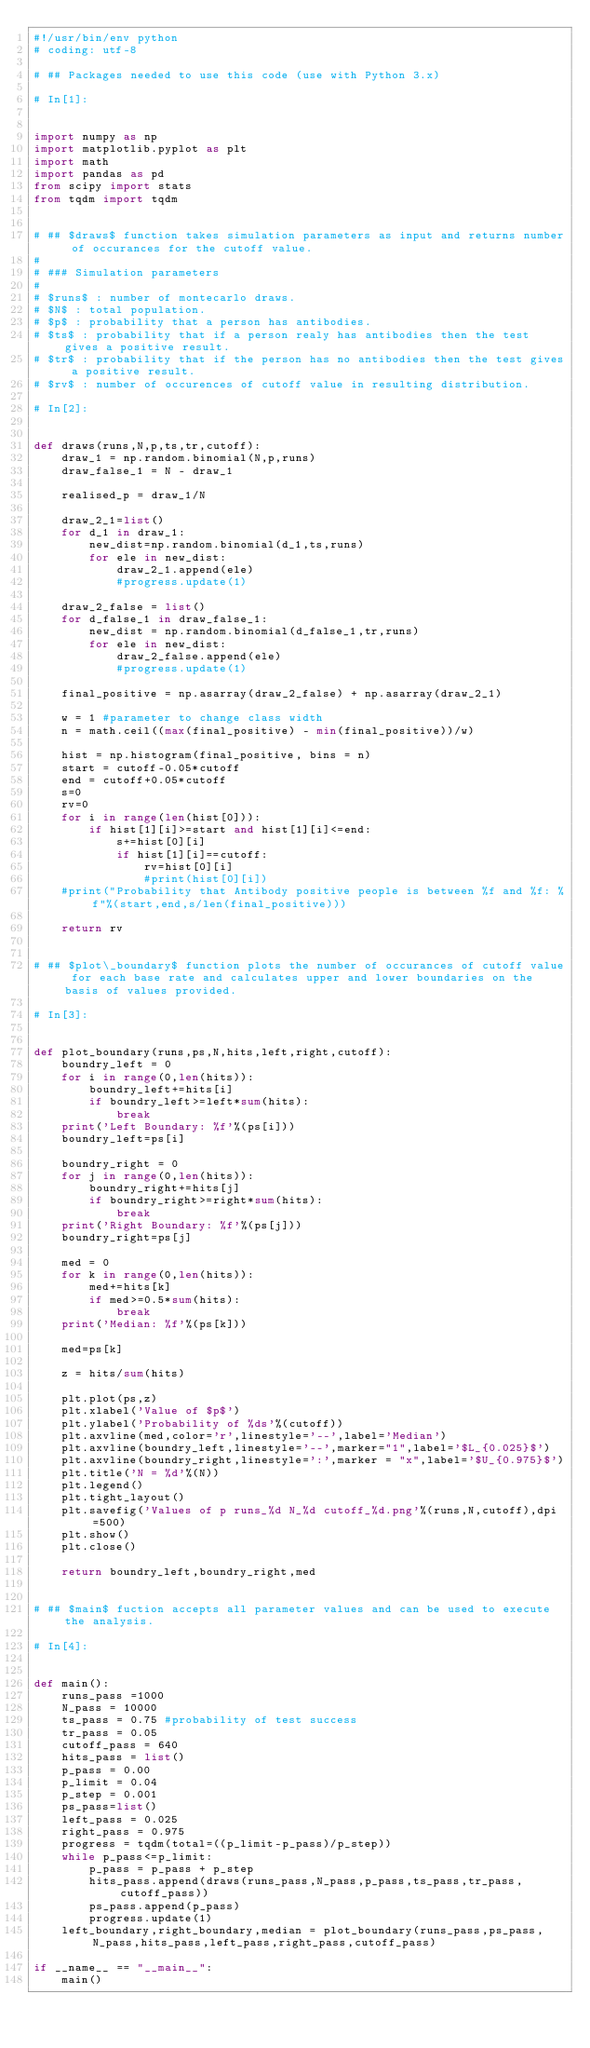<code> <loc_0><loc_0><loc_500><loc_500><_Python_>#!/usr/bin/env python
# coding: utf-8

# ## Packages needed to use this code (use with Python 3.x)

# In[1]:


import numpy as np
import matplotlib.pyplot as plt
import math
import pandas as pd
from scipy import stats
from tqdm import tqdm


# ## $draws$ function takes simulation parameters as input and returns number of occurances for the cutoff value.
# 
# ### Simulation parameters
# 
# $runs$ : number of montecarlo draws.  
# $N$ : total population.  
# $p$ : probability that a person has antibodies.  
# $ts$ : probability that if a person realy has antibodies then the test gives a positive result.  
# $tr$ : probability that if the person has no antibodies then the test gives a positive result.  
# $rv$ : number of occurences of cutoff value in resulting distribution.  

# In[2]:


def draws(runs,N,p,ts,tr,cutoff):
    draw_1 = np.random.binomial(N,p,runs)
    draw_false_1 = N - draw_1

    realised_p = draw_1/N

    draw_2_1=list()
    for d_1 in draw_1:
        new_dist=np.random.binomial(d_1,ts,runs)
        for ele in new_dist:
            draw_2_1.append(ele)
            #progress.update(1)

    draw_2_false = list()
    for d_false_1 in draw_false_1:
        new_dist = np.random.binomial(d_false_1,tr,runs)
        for ele in new_dist:
            draw_2_false.append(ele)
            #progress.update(1)

    final_positive = np.asarray(draw_2_false) + np.asarray(draw_2_1)

    w = 1 #parameter to change class width
    n = math.ceil((max(final_positive) - min(final_positive))/w)

    hist = np.histogram(final_positive, bins = n)
    start = cutoff-0.05*cutoff
    end = cutoff+0.05*cutoff
    s=0
    rv=0
    for i in range(len(hist[0])):
        if hist[1][i]>=start and hist[1][i]<=end:
            s+=hist[0][i]
            if hist[1][i]==cutoff:
                rv=hist[0][i]
                #print(hist[0][i])
    #print("Probability that Antibody positive people is between %f and %f: %f"%(start,end,s/len(final_positive)))

    return rv


# ## $plot\_boundary$ function plots the number of occurances of cutoff value for each base rate and calculates upper and lower boundaries on the basis of values provided.

# In[3]:


def plot_boundary(runs,ps,N,hits,left,right,cutoff):
    boundry_left = 0
    for i in range(0,len(hits)):
        boundry_left+=hits[i]
        if boundry_left>=left*sum(hits):
            break
    print('Left Boundary: %f'%(ps[i]))
    boundry_left=ps[i]

    boundry_right = 0
    for j in range(0,len(hits)):
        boundry_right+=hits[j]
        if boundry_right>=right*sum(hits):
            break
    print('Right Boundary: %f'%(ps[j]))
    boundry_right=ps[j]

    med = 0
    for k in range(0,len(hits)):
        med+=hits[k]
        if med>=0.5*sum(hits):
            break
    print('Median: %f'%(ps[k]))

    med=ps[k]

    z = hits/sum(hits)

    plt.plot(ps,z)
    plt.xlabel('Value of $p$')
    plt.ylabel('Probability of %ds'%(cutoff))
    plt.axvline(med,color='r',linestyle='--',label='Median')
    plt.axvline(boundry_left,linestyle='--',marker="1",label='$L_{0.025}$')
    plt.axvline(boundry_right,linestyle=':',marker = "x",label='$U_{0.975}$')
    plt.title('N = %d'%(N))
    plt.legend()
    plt.tight_layout()
    plt.savefig('Values of p runs_%d N_%d cutoff_%d.png'%(runs,N,cutoff),dpi=500)
    plt.show()
    plt.close()
    
    return boundry_left,boundry_right,med


# ## $main$ fuction accepts all parameter values and can be used to execute the analysis.

# In[4]:


def main():
    runs_pass =1000
    N_pass = 10000
    ts_pass = 0.75 #probability of test success
    tr_pass = 0.05
    cutoff_pass = 640
    hits_pass = list()
    p_pass = 0.00
    p_limit = 0.04
    p_step = 0.001
    ps_pass=list()
    left_pass = 0.025
    right_pass = 0.975
    progress = tqdm(total=((p_limit-p_pass)/p_step))
    while p_pass<=p_limit:
        p_pass = p_pass + p_step
        hits_pass.append(draws(runs_pass,N_pass,p_pass,ts_pass,tr_pass,cutoff_pass))
        ps_pass.append(p_pass)
        progress.update(1)
    left_boundary,right_boundary,median = plot_boundary(runs_pass,ps_pass,N_pass,hits_pass,left_pass,right_pass,cutoff_pass)

if __name__ == "__main__":
    main()

</code> 